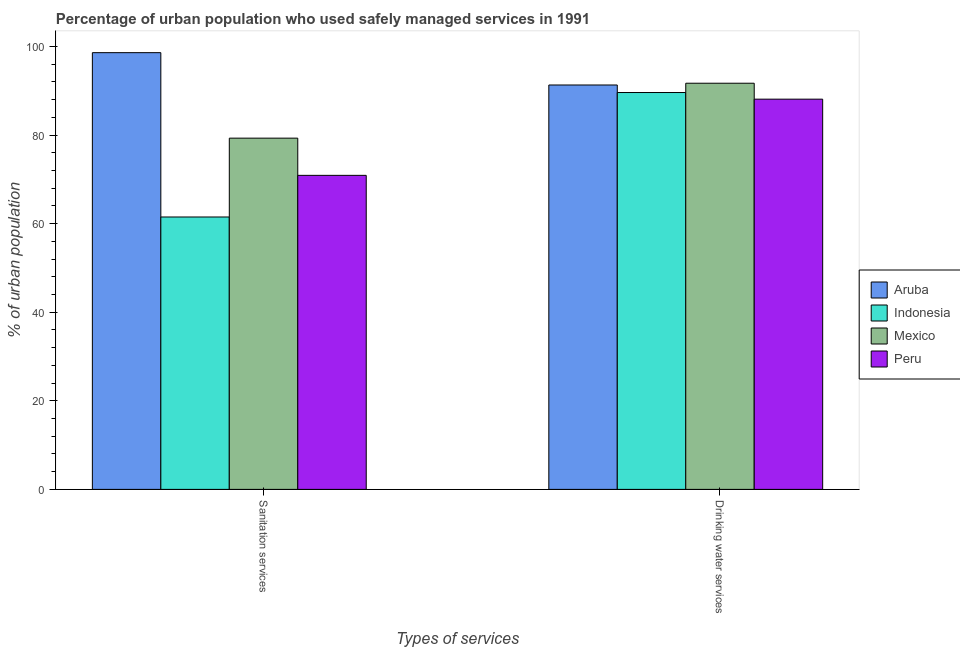How many different coloured bars are there?
Your response must be concise. 4. Are the number of bars per tick equal to the number of legend labels?
Make the answer very short. Yes. Are the number of bars on each tick of the X-axis equal?
Give a very brief answer. Yes. What is the label of the 1st group of bars from the left?
Offer a very short reply. Sanitation services. What is the percentage of urban population who used drinking water services in Mexico?
Offer a terse response. 91.7. Across all countries, what is the maximum percentage of urban population who used drinking water services?
Give a very brief answer. 91.7. Across all countries, what is the minimum percentage of urban population who used sanitation services?
Keep it short and to the point. 61.5. In which country was the percentage of urban population who used sanitation services maximum?
Keep it short and to the point. Aruba. What is the total percentage of urban population who used drinking water services in the graph?
Keep it short and to the point. 360.7. What is the difference between the percentage of urban population who used drinking water services in Aruba and that in Mexico?
Ensure brevity in your answer.  -0.4. What is the average percentage of urban population who used drinking water services per country?
Make the answer very short. 90.17. What is the difference between the percentage of urban population who used drinking water services and percentage of urban population who used sanitation services in Mexico?
Keep it short and to the point. 12.4. What is the ratio of the percentage of urban population who used sanitation services in Aruba to that in Peru?
Offer a terse response. 1.39. Is the percentage of urban population who used drinking water services in Indonesia less than that in Aruba?
Offer a terse response. Yes. What does the 2nd bar from the right in Drinking water services represents?
Your answer should be compact. Mexico. How many bars are there?
Keep it short and to the point. 8. What is the difference between two consecutive major ticks on the Y-axis?
Your answer should be very brief. 20. Are the values on the major ticks of Y-axis written in scientific E-notation?
Offer a very short reply. No. Does the graph contain grids?
Your response must be concise. No. Where does the legend appear in the graph?
Provide a succinct answer. Center right. What is the title of the graph?
Give a very brief answer. Percentage of urban population who used safely managed services in 1991. What is the label or title of the X-axis?
Make the answer very short. Types of services. What is the label or title of the Y-axis?
Provide a succinct answer. % of urban population. What is the % of urban population in Aruba in Sanitation services?
Your response must be concise. 98.6. What is the % of urban population in Indonesia in Sanitation services?
Make the answer very short. 61.5. What is the % of urban population in Mexico in Sanitation services?
Give a very brief answer. 79.3. What is the % of urban population of Peru in Sanitation services?
Your answer should be very brief. 70.9. What is the % of urban population of Aruba in Drinking water services?
Offer a terse response. 91.3. What is the % of urban population of Indonesia in Drinking water services?
Offer a very short reply. 89.6. What is the % of urban population in Mexico in Drinking water services?
Keep it short and to the point. 91.7. What is the % of urban population in Peru in Drinking water services?
Provide a succinct answer. 88.1. Across all Types of services, what is the maximum % of urban population in Aruba?
Ensure brevity in your answer.  98.6. Across all Types of services, what is the maximum % of urban population of Indonesia?
Keep it short and to the point. 89.6. Across all Types of services, what is the maximum % of urban population in Mexico?
Provide a short and direct response. 91.7. Across all Types of services, what is the maximum % of urban population in Peru?
Your answer should be compact. 88.1. Across all Types of services, what is the minimum % of urban population in Aruba?
Your response must be concise. 91.3. Across all Types of services, what is the minimum % of urban population in Indonesia?
Offer a terse response. 61.5. Across all Types of services, what is the minimum % of urban population in Mexico?
Give a very brief answer. 79.3. Across all Types of services, what is the minimum % of urban population of Peru?
Provide a short and direct response. 70.9. What is the total % of urban population of Aruba in the graph?
Make the answer very short. 189.9. What is the total % of urban population of Indonesia in the graph?
Your answer should be compact. 151.1. What is the total % of urban population of Mexico in the graph?
Offer a terse response. 171. What is the total % of urban population in Peru in the graph?
Keep it short and to the point. 159. What is the difference between the % of urban population of Aruba in Sanitation services and that in Drinking water services?
Make the answer very short. 7.3. What is the difference between the % of urban population of Indonesia in Sanitation services and that in Drinking water services?
Provide a succinct answer. -28.1. What is the difference between the % of urban population of Mexico in Sanitation services and that in Drinking water services?
Your response must be concise. -12.4. What is the difference between the % of urban population of Peru in Sanitation services and that in Drinking water services?
Provide a succinct answer. -17.2. What is the difference between the % of urban population of Aruba in Sanitation services and the % of urban population of Indonesia in Drinking water services?
Your response must be concise. 9. What is the difference between the % of urban population of Aruba in Sanitation services and the % of urban population of Peru in Drinking water services?
Your response must be concise. 10.5. What is the difference between the % of urban population in Indonesia in Sanitation services and the % of urban population in Mexico in Drinking water services?
Give a very brief answer. -30.2. What is the difference between the % of urban population in Indonesia in Sanitation services and the % of urban population in Peru in Drinking water services?
Make the answer very short. -26.6. What is the difference between the % of urban population of Mexico in Sanitation services and the % of urban population of Peru in Drinking water services?
Provide a succinct answer. -8.8. What is the average % of urban population in Aruba per Types of services?
Your answer should be very brief. 94.95. What is the average % of urban population in Indonesia per Types of services?
Provide a succinct answer. 75.55. What is the average % of urban population of Mexico per Types of services?
Ensure brevity in your answer.  85.5. What is the average % of urban population of Peru per Types of services?
Make the answer very short. 79.5. What is the difference between the % of urban population in Aruba and % of urban population in Indonesia in Sanitation services?
Keep it short and to the point. 37.1. What is the difference between the % of urban population in Aruba and % of urban population in Mexico in Sanitation services?
Provide a succinct answer. 19.3. What is the difference between the % of urban population in Aruba and % of urban population in Peru in Sanitation services?
Your response must be concise. 27.7. What is the difference between the % of urban population in Indonesia and % of urban population in Mexico in Sanitation services?
Ensure brevity in your answer.  -17.8. What is the difference between the % of urban population of Indonesia and % of urban population of Peru in Sanitation services?
Provide a short and direct response. -9.4. What is the difference between the % of urban population of Mexico and % of urban population of Peru in Sanitation services?
Make the answer very short. 8.4. What is the difference between the % of urban population of Aruba and % of urban population of Mexico in Drinking water services?
Offer a terse response. -0.4. What is the difference between the % of urban population of Indonesia and % of urban population of Mexico in Drinking water services?
Keep it short and to the point. -2.1. What is the difference between the % of urban population of Indonesia and % of urban population of Peru in Drinking water services?
Keep it short and to the point. 1.5. What is the difference between the % of urban population in Mexico and % of urban population in Peru in Drinking water services?
Your response must be concise. 3.6. What is the ratio of the % of urban population of Aruba in Sanitation services to that in Drinking water services?
Make the answer very short. 1.08. What is the ratio of the % of urban population of Indonesia in Sanitation services to that in Drinking water services?
Offer a terse response. 0.69. What is the ratio of the % of urban population of Mexico in Sanitation services to that in Drinking water services?
Provide a short and direct response. 0.86. What is the ratio of the % of urban population of Peru in Sanitation services to that in Drinking water services?
Provide a succinct answer. 0.8. What is the difference between the highest and the second highest % of urban population of Indonesia?
Offer a terse response. 28.1. What is the difference between the highest and the lowest % of urban population of Indonesia?
Offer a terse response. 28.1. 